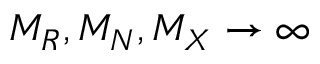Convert formula to latex. <formula><loc_0><loc_0><loc_500><loc_500>M _ { R } , M _ { N } , M _ { X } \rightarrow \infty</formula> 